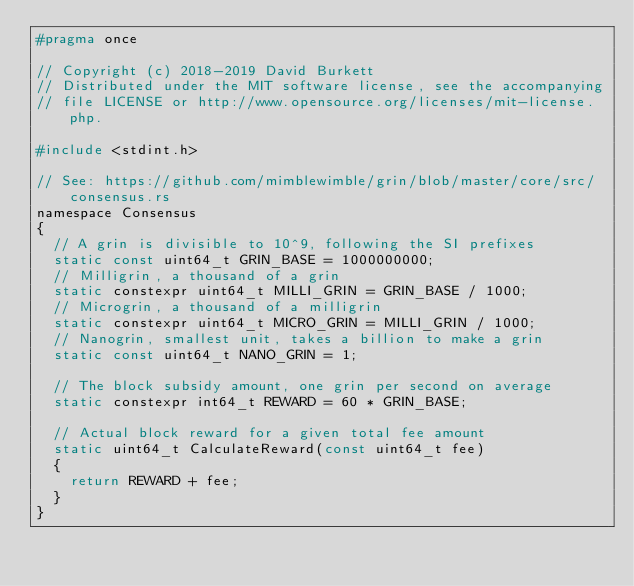<code> <loc_0><loc_0><loc_500><loc_500><_C_>#pragma once

// Copyright (c) 2018-2019 David Burkett
// Distributed under the MIT software license, see the accompanying
// file LICENSE or http://www.opensource.org/licenses/mit-license.php.

#include <stdint.h>

// See: https://github.com/mimblewimble/grin/blob/master/core/src/consensus.rs
namespace Consensus
{
	// A grin is divisible to 10^9, following the SI prefixes
	static const uint64_t GRIN_BASE = 1000000000;
	// Milligrin, a thousand of a grin
	static constexpr uint64_t MILLI_GRIN = GRIN_BASE / 1000;
	// Microgrin, a thousand of a milligrin
	static constexpr uint64_t MICRO_GRIN = MILLI_GRIN / 1000;
	// Nanogrin, smallest unit, takes a billion to make a grin
	static const uint64_t NANO_GRIN = 1;

	// The block subsidy amount, one grin per second on average
	static constexpr int64_t REWARD = 60 * GRIN_BASE;

	// Actual block reward for a given total fee amount
	static uint64_t CalculateReward(const uint64_t fee)
	{
		return REWARD + fee;
	}
}</code> 